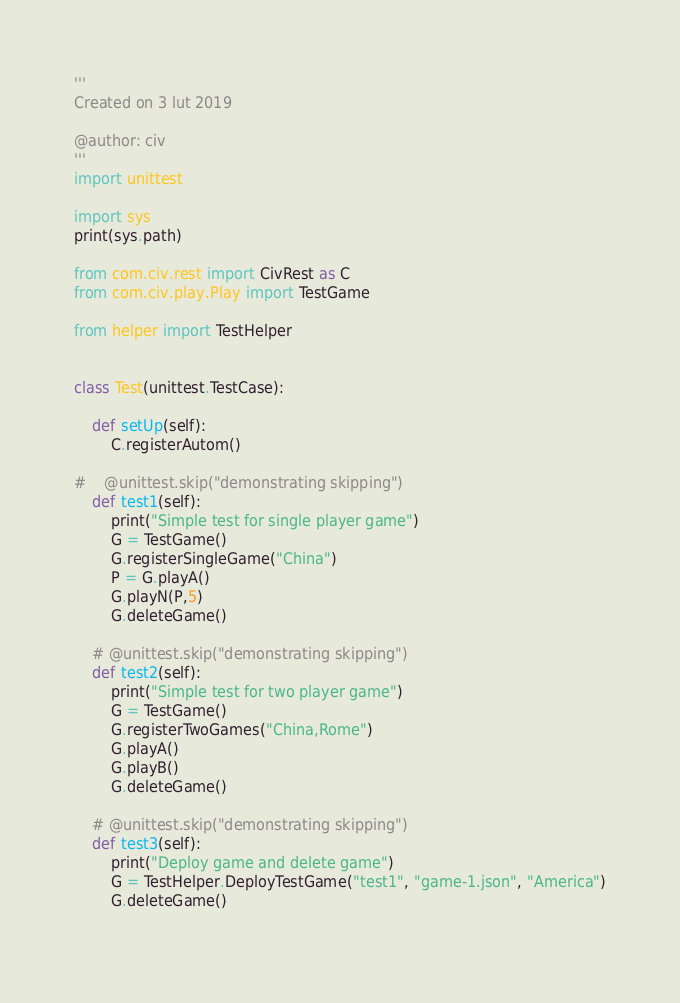<code> <loc_0><loc_0><loc_500><loc_500><_Python_>'''
Created on 3 lut 2019

@author: civ
'''
import unittest

import sys
print(sys.path)

from com.civ.rest import CivRest as C
from com.civ.play.Play import TestGame

from helper import TestHelper


class Test(unittest.TestCase):
    
    def setUp(self):
        C.registerAutom()

#    @unittest.skip("demonstrating skipping")
    def test1(self):
        print("Simple test for single player game")
        G = TestGame()
        G.registerSingleGame("China")
        P = G.playA()
        G.playN(P,5)
        G.deleteGame()

    # @unittest.skip("demonstrating skipping")        
    def test2(self):
        print("Simple test for two player game")
        G = TestGame()
        G.registerTwoGames("China,Rome")
        G.playA()
        G.playB()
        G.deleteGame()
        
    # @unittest.skip("demonstrating skipping")        
    def test3(self):
        print("Deploy game and delete game")
        G = TestHelper.DeployTestGame("test1", "game-1.json", "America")
        G.deleteGame()
        
</code> 